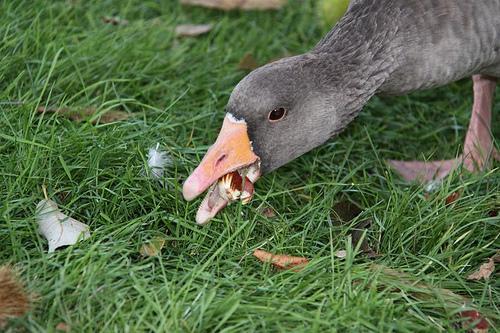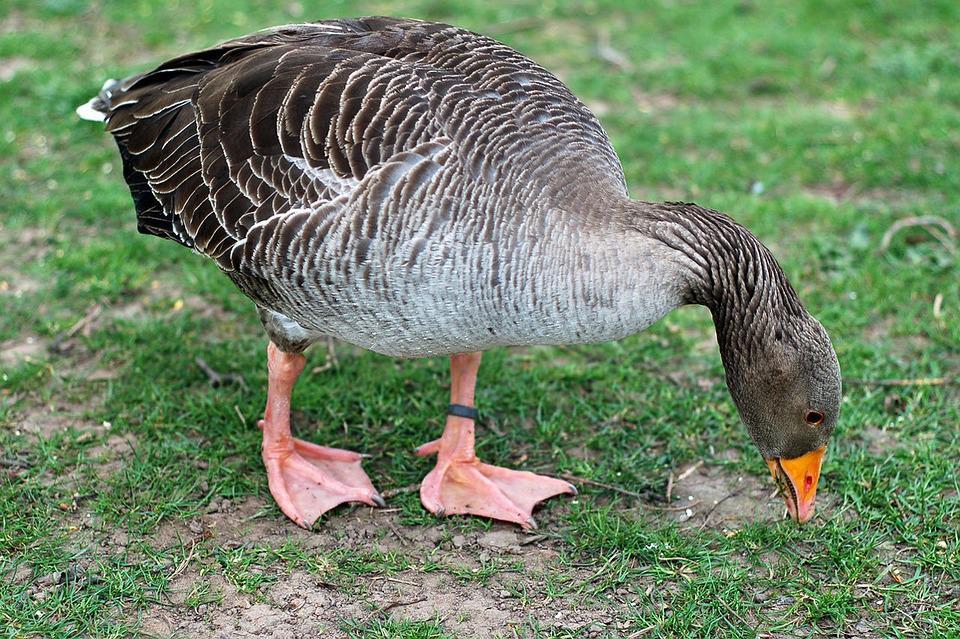The first image is the image on the left, the second image is the image on the right. Examine the images to the left and right. Is the description "The combined images include two geese with grey coloring bending their grey necks toward the grass." accurate? Answer yes or no. Yes. The first image is the image on the left, the second image is the image on the right. Considering the images on both sides, is "The right image contains exactly one duck." valid? Answer yes or no. Yes. 